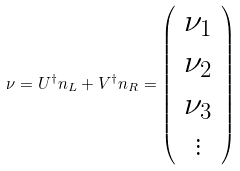<formula> <loc_0><loc_0><loc_500><loc_500>\nu = U ^ { \dag } n _ { L } + V ^ { \dag } n _ { R } = \left ( \begin{array} { c } \nu _ { 1 } \\ \nu _ { 2 } \\ \nu _ { 3 } \\ \vdots \\ \end{array} \right )</formula> 